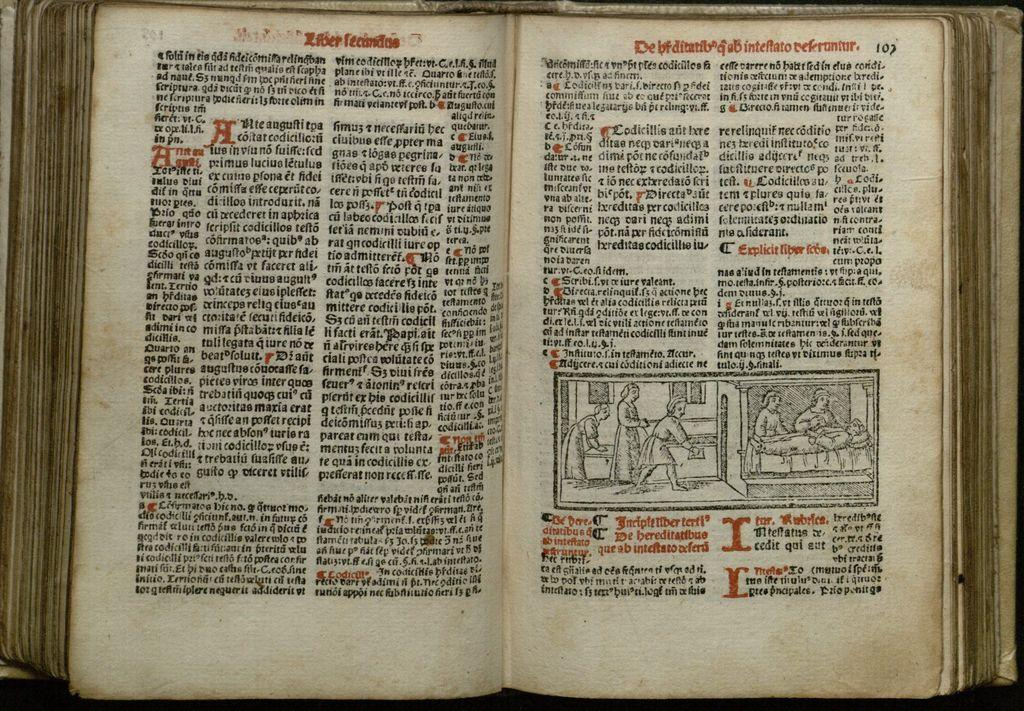<image>
Present a compact description of the photo's key features. A very old book written in what might be Latin is open to page 107. 